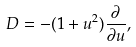<formula> <loc_0><loc_0><loc_500><loc_500>D = - ( 1 + u ^ { 2 } ) \frac { \partial } { \partial u } ,</formula> 